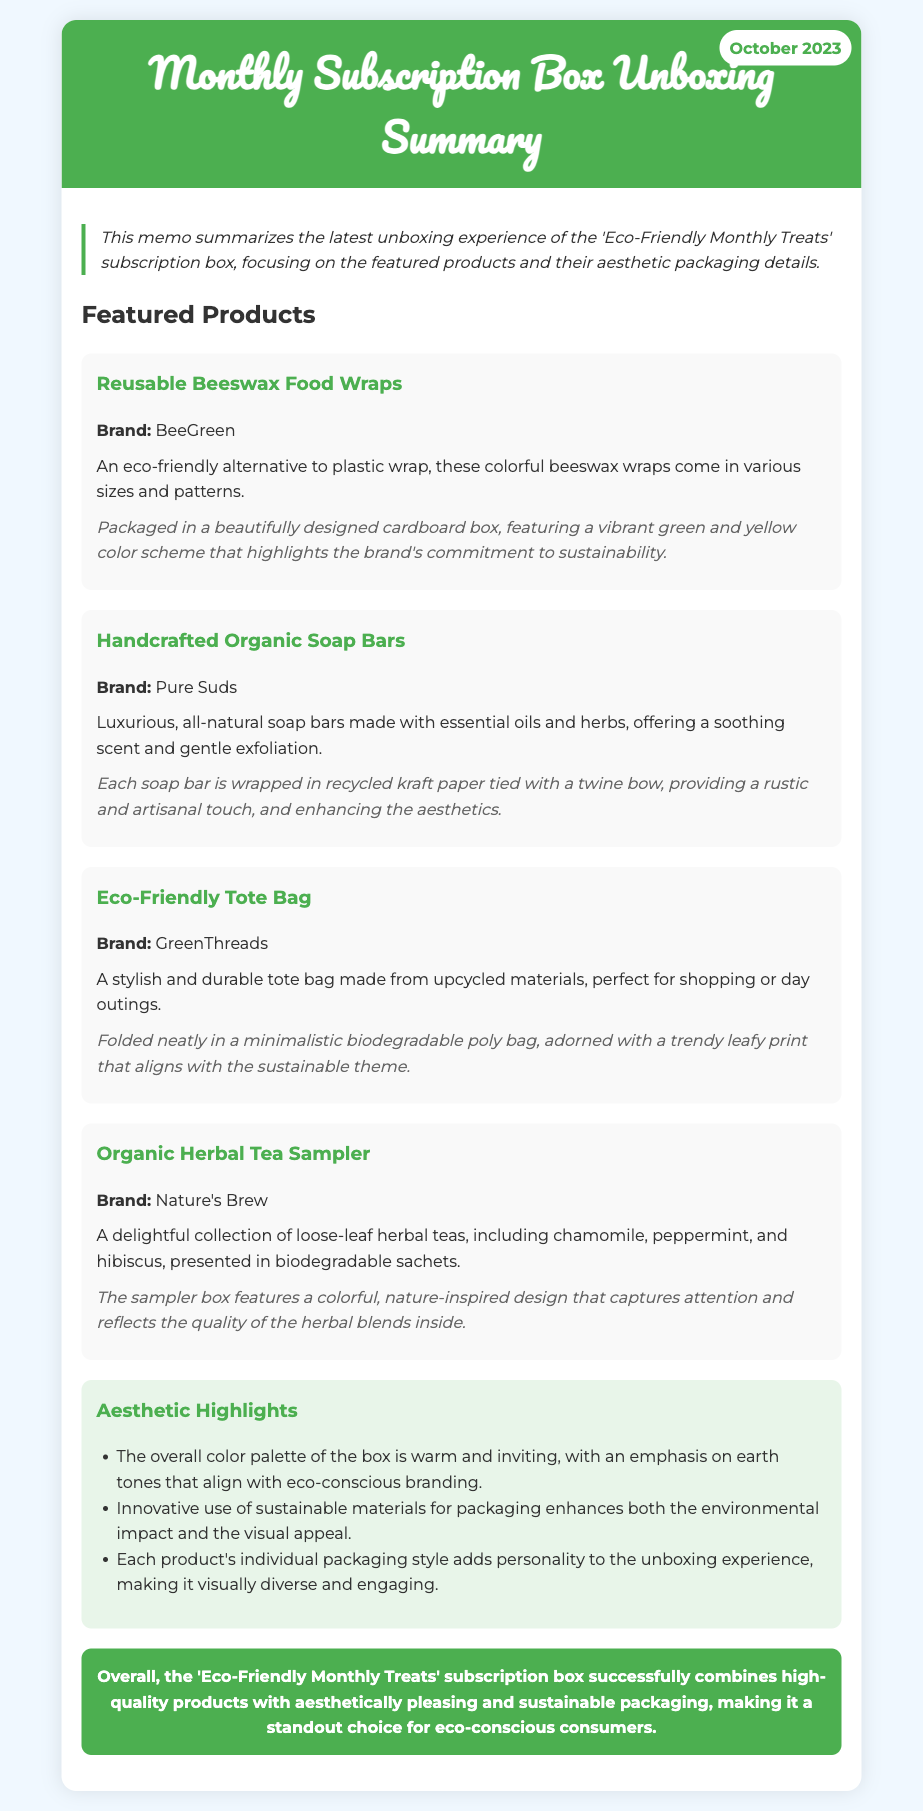What is the date of the memo? The date of the memo is displayed clearly in the header section of the document.
Answer: October 2023 What is the first featured product? The first featured product is listed under the "Featured Products" section, which details various items in the subscription box.
Answer: Reusable Beeswax Food Wraps Who is the brand of the eco-friendly tote bag? The brand name is provided in the product details for the eco-friendly tote bag.
Answer: GreenThreads What is one of the herbal tea varieties included in the sampler? The document lists the types of herbal teas included in the sampler box.
Answer: Chamomile How are the handcrafted organic soap bars packaged? The packaging details are included in the description of the soap bars, providing insight into their presentation.
Answer: Wrapped in recycled kraft paper tied with a twine bow What color scheme is used for the beeswax wraps packaging? The color scheme is particularly mentioned in the packaging details of the beeswax wraps.
Answer: Vibrant green and yellow What material is the eco-friendly tote bag made from? The material is highlighted in the product description of the tote bag, indicating its sustainable aspect.
Answer: Upcycled materials How does the sampler box's design reflect its contents? The document discusses the design of the sampler box in relation to its contents.
Answer: Nature-inspired design What theme is aligned with the overall aesthetics of the subscription box? The memo describes the overall visual theme associated with the subscription box items and their packaging.
Answer: Eco-conscious 